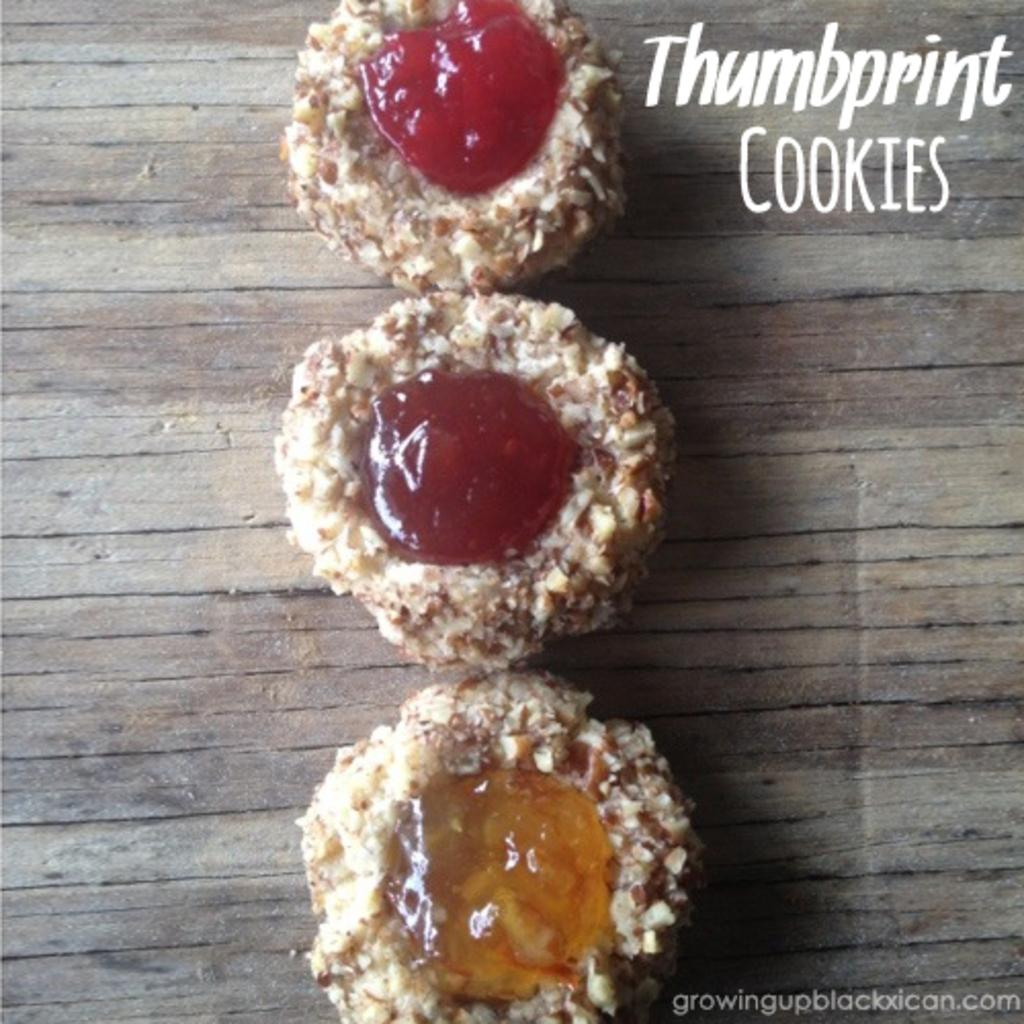What can be seen in the image? There is food in the image. Can you describe any specific details about the food be identified? Yes, there is text written on the food. What type of guide is present in the image? There is no guide present in the image; it only features food with text written on it. 